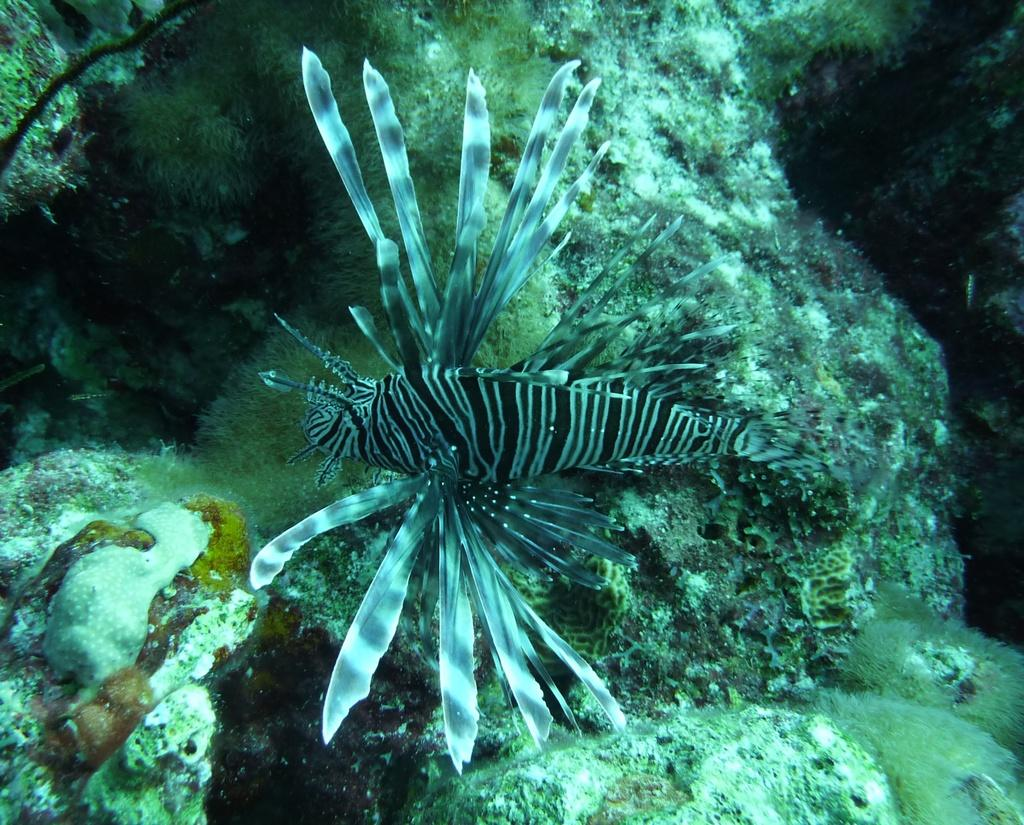What type of animal is present in the image? There is an aquatic animal in the image. Can you describe the color pattern of the aquatic animal? The aquatic animal is white and black in color. Where is the stone located in the image? There is no stone present in the image. What type of sink is visible in the image? There is no sink present in the image. 